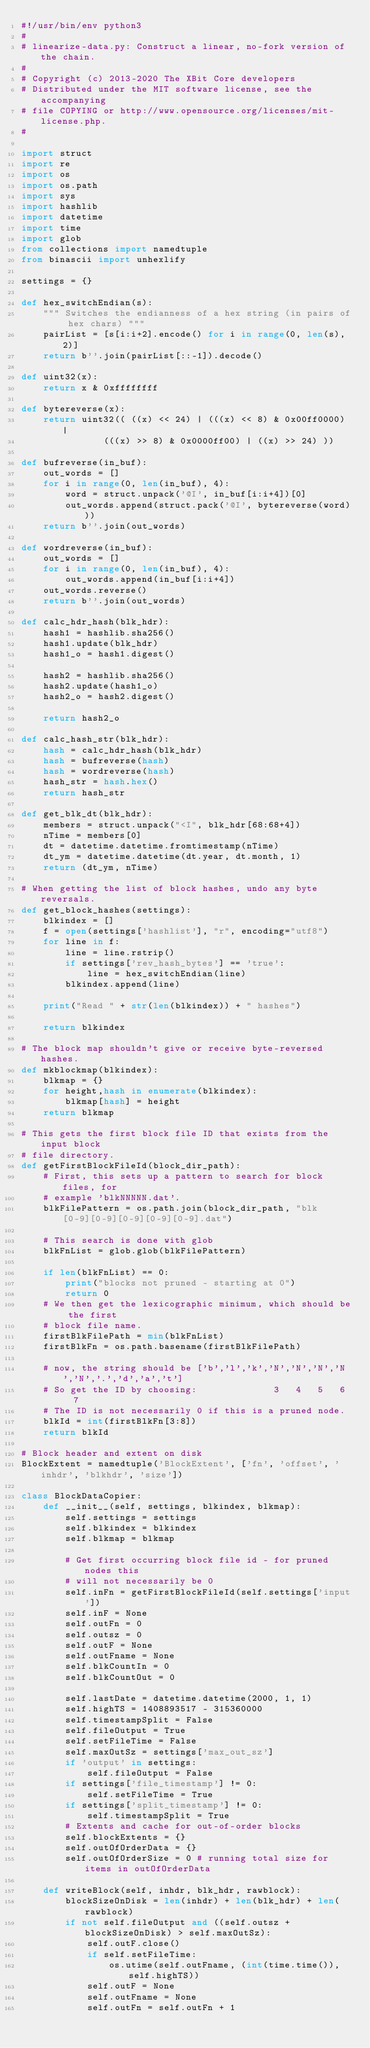Convert code to text. <code><loc_0><loc_0><loc_500><loc_500><_Python_>#!/usr/bin/env python3
#
# linearize-data.py: Construct a linear, no-fork version of the chain.
#
# Copyright (c) 2013-2020 The XBit Core developers
# Distributed under the MIT software license, see the accompanying
# file COPYING or http://www.opensource.org/licenses/mit-license.php.
#

import struct
import re
import os
import os.path
import sys
import hashlib
import datetime
import time
import glob
from collections import namedtuple
from binascii import unhexlify

settings = {}

def hex_switchEndian(s):
    """ Switches the endianness of a hex string (in pairs of hex chars) """
    pairList = [s[i:i+2].encode() for i in range(0, len(s), 2)]
    return b''.join(pairList[::-1]).decode()

def uint32(x):
    return x & 0xffffffff

def bytereverse(x):
    return uint32(( ((x) << 24) | (((x) << 8) & 0x00ff0000) |
               (((x) >> 8) & 0x0000ff00) | ((x) >> 24) ))

def bufreverse(in_buf):
    out_words = []
    for i in range(0, len(in_buf), 4):
        word = struct.unpack('@I', in_buf[i:i+4])[0]
        out_words.append(struct.pack('@I', bytereverse(word)))
    return b''.join(out_words)

def wordreverse(in_buf):
    out_words = []
    for i in range(0, len(in_buf), 4):
        out_words.append(in_buf[i:i+4])
    out_words.reverse()
    return b''.join(out_words)

def calc_hdr_hash(blk_hdr):
    hash1 = hashlib.sha256()
    hash1.update(blk_hdr)
    hash1_o = hash1.digest()

    hash2 = hashlib.sha256()
    hash2.update(hash1_o)
    hash2_o = hash2.digest()

    return hash2_o

def calc_hash_str(blk_hdr):
    hash = calc_hdr_hash(blk_hdr)
    hash = bufreverse(hash)
    hash = wordreverse(hash)
    hash_str = hash.hex()
    return hash_str

def get_blk_dt(blk_hdr):
    members = struct.unpack("<I", blk_hdr[68:68+4])
    nTime = members[0]
    dt = datetime.datetime.fromtimestamp(nTime)
    dt_ym = datetime.datetime(dt.year, dt.month, 1)
    return (dt_ym, nTime)

# When getting the list of block hashes, undo any byte reversals.
def get_block_hashes(settings):
    blkindex = []
    f = open(settings['hashlist'], "r", encoding="utf8")
    for line in f:
        line = line.rstrip()
        if settings['rev_hash_bytes'] == 'true':
            line = hex_switchEndian(line)
        blkindex.append(line)

    print("Read " + str(len(blkindex)) + " hashes")

    return blkindex

# The block map shouldn't give or receive byte-reversed hashes.
def mkblockmap(blkindex):
    blkmap = {}
    for height,hash in enumerate(blkindex):
        blkmap[hash] = height
    return blkmap

# This gets the first block file ID that exists from the input block
# file directory.
def getFirstBlockFileId(block_dir_path):
    # First, this sets up a pattern to search for block files, for
    # example 'blkNNNNN.dat'.
    blkFilePattern = os.path.join(block_dir_path, "blk[0-9][0-9][0-9][0-9][0-9].dat")

    # This search is done with glob
    blkFnList = glob.glob(blkFilePattern)

    if len(blkFnList) == 0:
        print("blocks not pruned - starting at 0")
        return 0
    # We then get the lexicographic minimum, which should be the first
    # block file name.
    firstBlkFilePath = min(blkFnList)
    firstBlkFn = os.path.basename(firstBlkFilePath)

    # now, the string should be ['b','l','k','N','N','N','N','N','.','d','a','t']
    # So get the ID by choosing:              3   4   5   6   7
    # The ID is not necessarily 0 if this is a pruned node.
    blkId = int(firstBlkFn[3:8])
    return blkId

# Block header and extent on disk
BlockExtent = namedtuple('BlockExtent', ['fn', 'offset', 'inhdr', 'blkhdr', 'size'])

class BlockDataCopier:
    def __init__(self, settings, blkindex, blkmap):
        self.settings = settings
        self.blkindex = blkindex
        self.blkmap = blkmap

        # Get first occurring block file id - for pruned nodes this
        # will not necessarily be 0
        self.inFn = getFirstBlockFileId(self.settings['input'])
        self.inF = None
        self.outFn = 0
        self.outsz = 0
        self.outF = None
        self.outFname = None
        self.blkCountIn = 0
        self.blkCountOut = 0

        self.lastDate = datetime.datetime(2000, 1, 1)
        self.highTS = 1408893517 - 315360000
        self.timestampSplit = False
        self.fileOutput = True
        self.setFileTime = False
        self.maxOutSz = settings['max_out_sz']
        if 'output' in settings:
            self.fileOutput = False
        if settings['file_timestamp'] != 0:
            self.setFileTime = True
        if settings['split_timestamp'] != 0:
            self.timestampSplit = True
        # Extents and cache for out-of-order blocks
        self.blockExtents = {}
        self.outOfOrderData = {}
        self.outOfOrderSize = 0 # running total size for items in outOfOrderData

    def writeBlock(self, inhdr, blk_hdr, rawblock):
        blockSizeOnDisk = len(inhdr) + len(blk_hdr) + len(rawblock)
        if not self.fileOutput and ((self.outsz + blockSizeOnDisk) > self.maxOutSz):
            self.outF.close()
            if self.setFileTime:
                os.utime(self.outFname, (int(time.time()), self.highTS))
            self.outF = None
            self.outFname = None
            self.outFn = self.outFn + 1</code> 